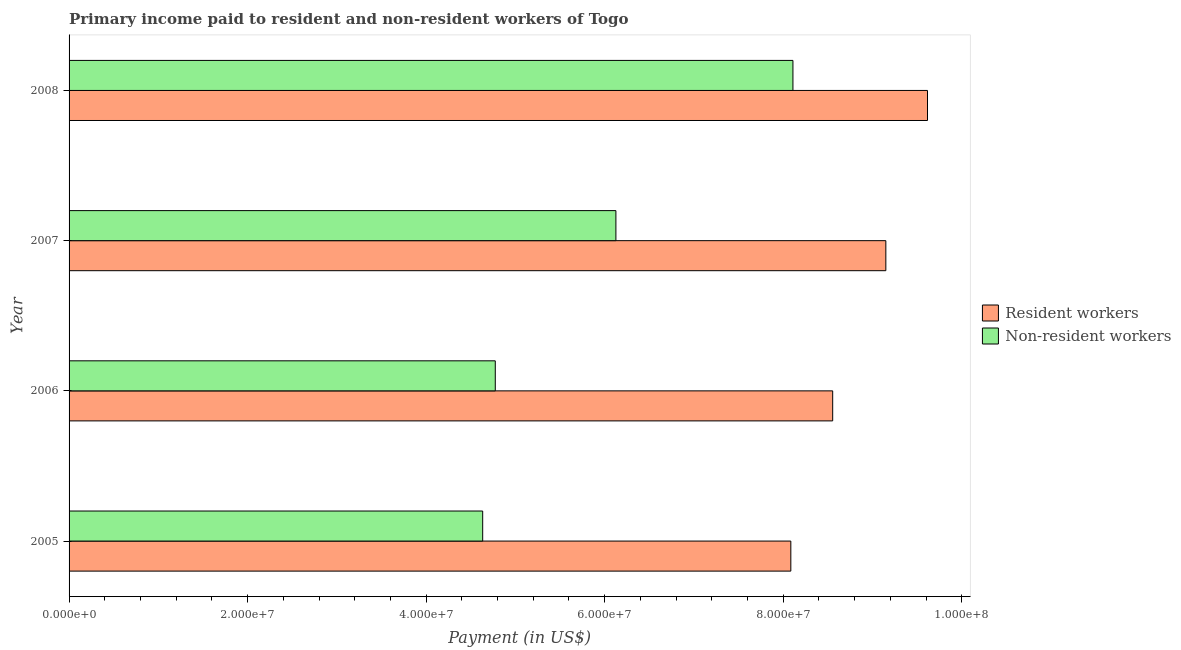How many groups of bars are there?
Offer a terse response. 4. Are the number of bars per tick equal to the number of legend labels?
Your answer should be compact. Yes. Are the number of bars on each tick of the Y-axis equal?
Offer a very short reply. Yes. How many bars are there on the 1st tick from the bottom?
Provide a succinct answer. 2. What is the payment made to non-resident workers in 2008?
Offer a very short reply. 8.11e+07. Across all years, what is the maximum payment made to resident workers?
Your answer should be very brief. 9.62e+07. Across all years, what is the minimum payment made to resident workers?
Your answer should be compact. 8.09e+07. In which year was the payment made to non-resident workers maximum?
Make the answer very short. 2008. What is the total payment made to resident workers in the graph?
Give a very brief answer. 3.54e+08. What is the difference between the payment made to resident workers in 2006 and that in 2008?
Make the answer very short. -1.06e+07. What is the difference between the payment made to non-resident workers in 2006 and the payment made to resident workers in 2007?
Ensure brevity in your answer.  -4.38e+07. What is the average payment made to resident workers per year?
Make the answer very short. 8.85e+07. In the year 2005, what is the difference between the payment made to resident workers and payment made to non-resident workers?
Provide a succinct answer. 3.45e+07. In how many years, is the payment made to resident workers greater than 40000000 US$?
Provide a short and direct response. 4. What is the ratio of the payment made to resident workers in 2005 to that in 2007?
Provide a succinct answer. 0.88. Is the payment made to non-resident workers in 2005 less than that in 2008?
Provide a short and direct response. Yes. What is the difference between the highest and the second highest payment made to non-resident workers?
Give a very brief answer. 1.98e+07. What is the difference between the highest and the lowest payment made to resident workers?
Provide a short and direct response. 1.53e+07. Is the sum of the payment made to resident workers in 2006 and 2007 greater than the maximum payment made to non-resident workers across all years?
Offer a terse response. Yes. What does the 2nd bar from the top in 2006 represents?
Ensure brevity in your answer.  Resident workers. What does the 2nd bar from the bottom in 2007 represents?
Offer a very short reply. Non-resident workers. How many years are there in the graph?
Give a very brief answer. 4. Does the graph contain grids?
Make the answer very short. No. Where does the legend appear in the graph?
Offer a terse response. Center right. How many legend labels are there?
Your response must be concise. 2. What is the title of the graph?
Offer a terse response. Primary income paid to resident and non-resident workers of Togo. Does "Urban agglomerations" appear as one of the legend labels in the graph?
Offer a terse response. No. What is the label or title of the X-axis?
Give a very brief answer. Payment (in US$). What is the label or title of the Y-axis?
Provide a succinct answer. Year. What is the Payment (in US$) in Resident workers in 2005?
Your response must be concise. 8.09e+07. What is the Payment (in US$) in Non-resident workers in 2005?
Your response must be concise. 4.63e+07. What is the Payment (in US$) of Resident workers in 2006?
Provide a short and direct response. 8.55e+07. What is the Payment (in US$) of Non-resident workers in 2006?
Give a very brief answer. 4.77e+07. What is the Payment (in US$) of Resident workers in 2007?
Your answer should be very brief. 9.15e+07. What is the Payment (in US$) of Non-resident workers in 2007?
Give a very brief answer. 6.13e+07. What is the Payment (in US$) of Resident workers in 2008?
Your answer should be very brief. 9.62e+07. What is the Payment (in US$) of Non-resident workers in 2008?
Provide a short and direct response. 8.11e+07. Across all years, what is the maximum Payment (in US$) of Resident workers?
Ensure brevity in your answer.  9.62e+07. Across all years, what is the maximum Payment (in US$) of Non-resident workers?
Keep it short and to the point. 8.11e+07. Across all years, what is the minimum Payment (in US$) in Resident workers?
Your answer should be very brief. 8.09e+07. Across all years, what is the minimum Payment (in US$) in Non-resident workers?
Give a very brief answer. 4.63e+07. What is the total Payment (in US$) in Resident workers in the graph?
Offer a terse response. 3.54e+08. What is the total Payment (in US$) in Non-resident workers in the graph?
Provide a short and direct response. 2.36e+08. What is the difference between the Payment (in US$) of Resident workers in 2005 and that in 2006?
Give a very brief answer. -4.69e+06. What is the difference between the Payment (in US$) of Non-resident workers in 2005 and that in 2006?
Provide a short and direct response. -1.41e+06. What is the difference between the Payment (in US$) in Resident workers in 2005 and that in 2007?
Ensure brevity in your answer.  -1.06e+07. What is the difference between the Payment (in US$) of Non-resident workers in 2005 and that in 2007?
Keep it short and to the point. -1.49e+07. What is the difference between the Payment (in US$) in Resident workers in 2005 and that in 2008?
Offer a terse response. -1.53e+07. What is the difference between the Payment (in US$) in Non-resident workers in 2005 and that in 2008?
Keep it short and to the point. -3.48e+07. What is the difference between the Payment (in US$) in Resident workers in 2006 and that in 2007?
Provide a short and direct response. -5.95e+06. What is the difference between the Payment (in US$) in Non-resident workers in 2006 and that in 2007?
Give a very brief answer. -1.35e+07. What is the difference between the Payment (in US$) of Resident workers in 2006 and that in 2008?
Offer a very short reply. -1.06e+07. What is the difference between the Payment (in US$) of Non-resident workers in 2006 and that in 2008?
Offer a very short reply. -3.33e+07. What is the difference between the Payment (in US$) of Resident workers in 2007 and that in 2008?
Give a very brief answer. -4.67e+06. What is the difference between the Payment (in US$) of Non-resident workers in 2007 and that in 2008?
Provide a succinct answer. -1.98e+07. What is the difference between the Payment (in US$) of Resident workers in 2005 and the Payment (in US$) of Non-resident workers in 2006?
Give a very brief answer. 3.31e+07. What is the difference between the Payment (in US$) in Resident workers in 2005 and the Payment (in US$) in Non-resident workers in 2007?
Offer a very short reply. 1.96e+07. What is the difference between the Payment (in US$) in Resident workers in 2005 and the Payment (in US$) in Non-resident workers in 2008?
Keep it short and to the point. -2.37e+05. What is the difference between the Payment (in US$) of Resident workers in 2006 and the Payment (in US$) of Non-resident workers in 2007?
Provide a succinct answer. 2.43e+07. What is the difference between the Payment (in US$) in Resident workers in 2006 and the Payment (in US$) in Non-resident workers in 2008?
Make the answer very short. 4.45e+06. What is the difference between the Payment (in US$) of Resident workers in 2007 and the Payment (in US$) of Non-resident workers in 2008?
Give a very brief answer. 1.04e+07. What is the average Payment (in US$) in Resident workers per year?
Ensure brevity in your answer.  8.85e+07. What is the average Payment (in US$) of Non-resident workers per year?
Offer a very short reply. 5.91e+07. In the year 2005, what is the difference between the Payment (in US$) of Resident workers and Payment (in US$) of Non-resident workers?
Keep it short and to the point. 3.45e+07. In the year 2006, what is the difference between the Payment (in US$) of Resident workers and Payment (in US$) of Non-resident workers?
Give a very brief answer. 3.78e+07. In the year 2007, what is the difference between the Payment (in US$) of Resident workers and Payment (in US$) of Non-resident workers?
Provide a succinct answer. 3.02e+07. In the year 2008, what is the difference between the Payment (in US$) of Resident workers and Payment (in US$) of Non-resident workers?
Your answer should be compact. 1.51e+07. What is the ratio of the Payment (in US$) of Resident workers in 2005 to that in 2006?
Ensure brevity in your answer.  0.95. What is the ratio of the Payment (in US$) in Non-resident workers in 2005 to that in 2006?
Make the answer very short. 0.97. What is the ratio of the Payment (in US$) of Resident workers in 2005 to that in 2007?
Give a very brief answer. 0.88. What is the ratio of the Payment (in US$) of Non-resident workers in 2005 to that in 2007?
Offer a terse response. 0.76. What is the ratio of the Payment (in US$) of Resident workers in 2005 to that in 2008?
Provide a succinct answer. 0.84. What is the ratio of the Payment (in US$) in Resident workers in 2006 to that in 2007?
Your answer should be compact. 0.93. What is the ratio of the Payment (in US$) in Non-resident workers in 2006 to that in 2007?
Give a very brief answer. 0.78. What is the ratio of the Payment (in US$) in Resident workers in 2006 to that in 2008?
Give a very brief answer. 0.89. What is the ratio of the Payment (in US$) of Non-resident workers in 2006 to that in 2008?
Offer a terse response. 0.59. What is the ratio of the Payment (in US$) in Resident workers in 2007 to that in 2008?
Offer a very short reply. 0.95. What is the ratio of the Payment (in US$) of Non-resident workers in 2007 to that in 2008?
Your response must be concise. 0.76. What is the difference between the highest and the second highest Payment (in US$) in Resident workers?
Provide a short and direct response. 4.67e+06. What is the difference between the highest and the second highest Payment (in US$) in Non-resident workers?
Your response must be concise. 1.98e+07. What is the difference between the highest and the lowest Payment (in US$) of Resident workers?
Offer a terse response. 1.53e+07. What is the difference between the highest and the lowest Payment (in US$) of Non-resident workers?
Make the answer very short. 3.48e+07. 